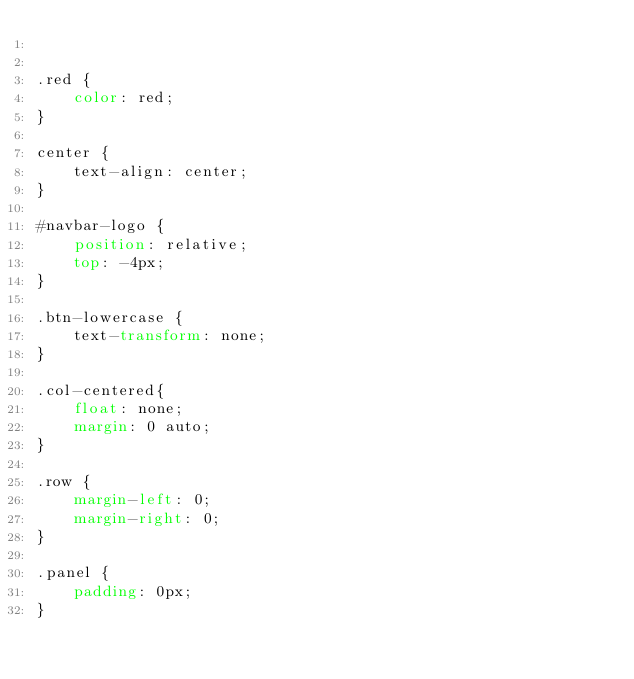<code> <loc_0><loc_0><loc_500><loc_500><_CSS_>

.red {
    color: red;
}

center {
    text-align: center;
}

#navbar-logo {
    position: relative;
    top: -4px;
}

.btn-lowercase {
    text-transform: none;
}

.col-centered{
    float: none;
    margin: 0 auto;
}

.row {
    margin-left: 0;
    margin-right: 0;
}

.panel {
    padding: 0px;
}
</code> 